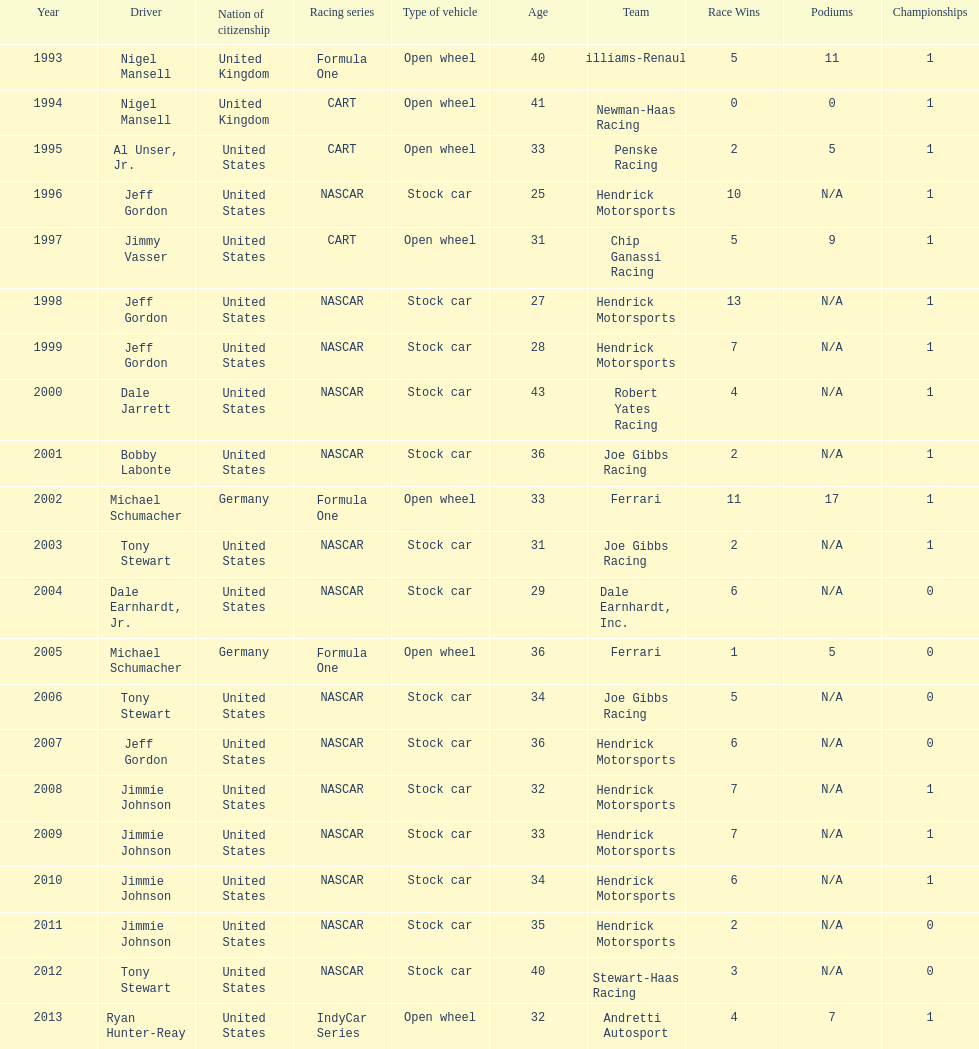How many times did jeff gordon win the award? 4. 